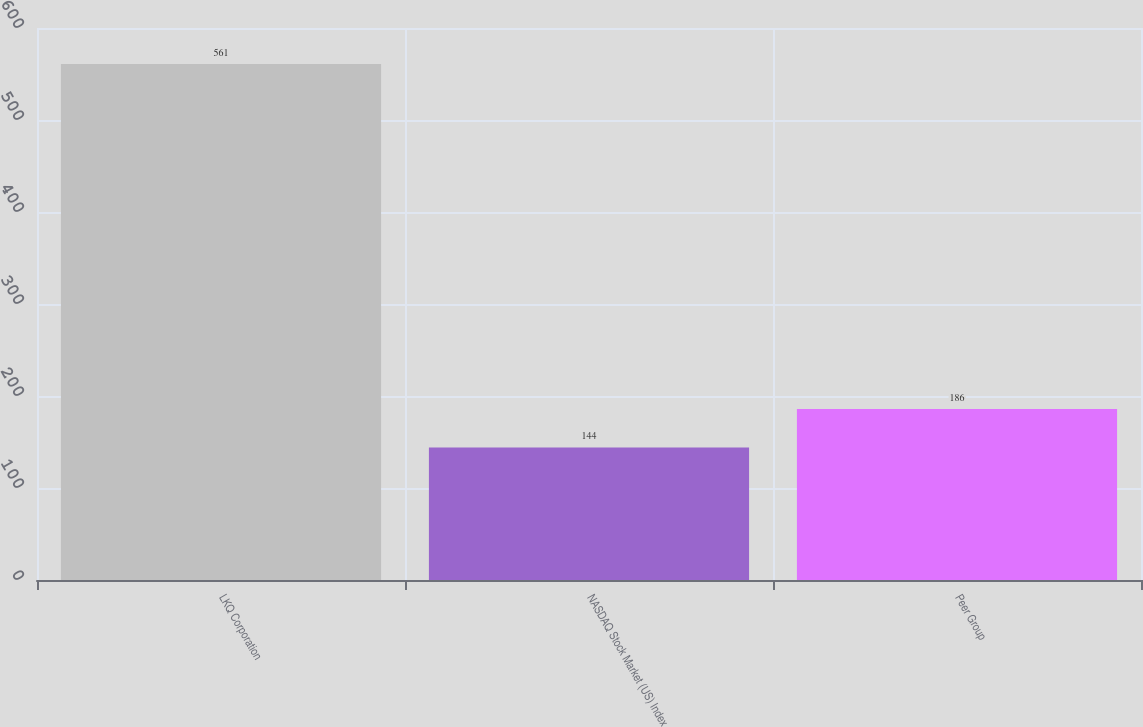<chart> <loc_0><loc_0><loc_500><loc_500><bar_chart><fcel>LKQ Corporation<fcel>NASDAQ Stock Market (US) Index<fcel>Peer Group<nl><fcel>561<fcel>144<fcel>186<nl></chart> 